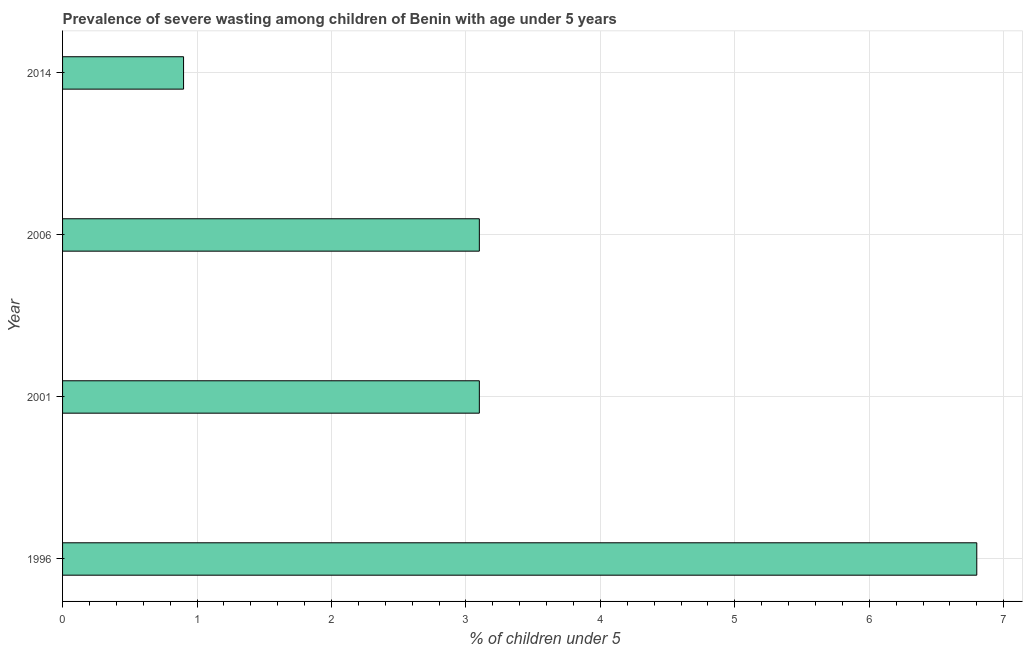What is the title of the graph?
Keep it short and to the point. Prevalence of severe wasting among children of Benin with age under 5 years. What is the label or title of the X-axis?
Provide a succinct answer.  % of children under 5. What is the prevalence of severe wasting in 2001?
Your answer should be compact. 3.1. Across all years, what is the maximum prevalence of severe wasting?
Provide a succinct answer. 6.8. Across all years, what is the minimum prevalence of severe wasting?
Your answer should be very brief. 0.9. What is the sum of the prevalence of severe wasting?
Give a very brief answer. 13.9. What is the difference between the prevalence of severe wasting in 1996 and 2006?
Your answer should be compact. 3.7. What is the average prevalence of severe wasting per year?
Give a very brief answer. 3.48. What is the median prevalence of severe wasting?
Provide a short and direct response. 3.1. Do a majority of the years between 2001 and 2006 (inclusive) have prevalence of severe wasting greater than 4.2 %?
Make the answer very short. No. What is the ratio of the prevalence of severe wasting in 2006 to that in 2014?
Make the answer very short. 3.44. Are all the bars in the graph horizontal?
Make the answer very short. Yes. How many years are there in the graph?
Keep it short and to the point. 4. What is the  % of children under 5 of 1996?
Your answer should be compact. 6.8. What is the  % of children under 5 of 2001?
Offer a very short reply. 3.1. What is the  % of children under 5 in 2006?
Ensure brevity in your answer.  3.1. What is the  % of children under 5 of 2014?
Your answer should be compact. 0.9. What is the difference between the  % of children under 5 in 1996 and 2014?
Ensure brevity in your answer.  5.9. What is the difference between the  % of children under 5 in 2001 and 2014?
Provide a succinct answer. 2.2. What is the ratio of the  % of children under 5 in 1996 to that in 2001?
Provide a short and direct response. 2.19. What is the ratio of the  % of children under 5 in 1996 to that in 2006?
Your answer should be very brief. 2.19. What is the ratio of the  % of children under 5 in 1996 to that in 2014?
Keep it short and to the point. 7.56. What is the ratio of the  % of children under 5 in 2001 to that in 2014?
Give a very brief answer. 3.44. What is the ratio of the  % of children under 5 in 2006 to that in 2014?
Offer a terse response. 3.44. 